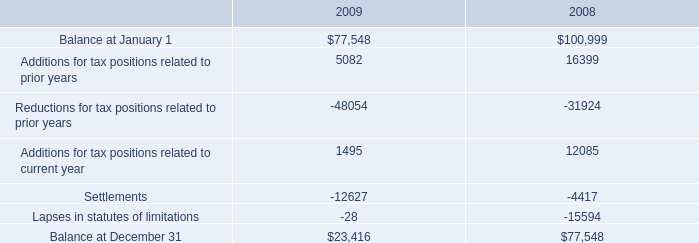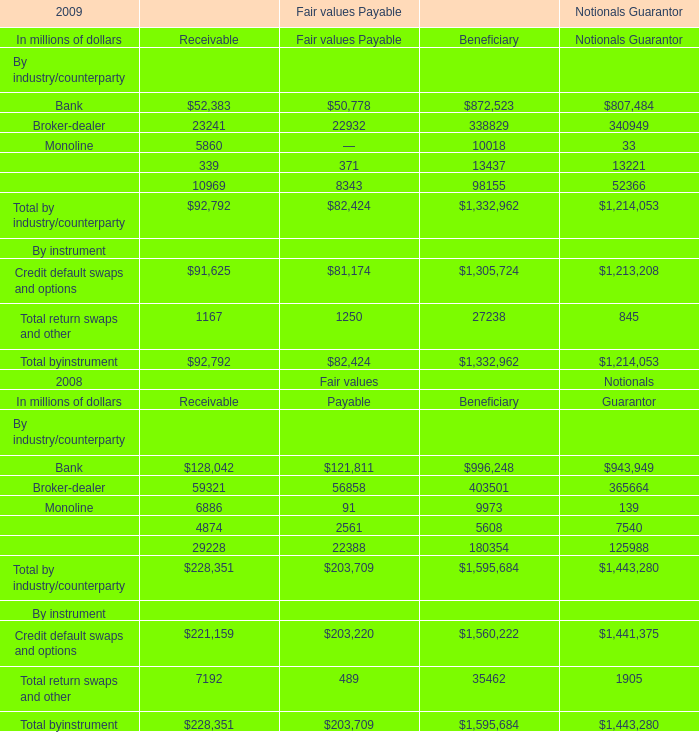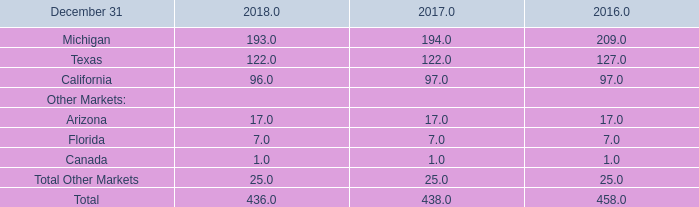What is the total amount of Additions for tax positions related to current year of 2008, and Monoline of Fair values Payable Receivable ? 
Computations: (12085.0 + 5860.0)
Answer: 17945.0. 